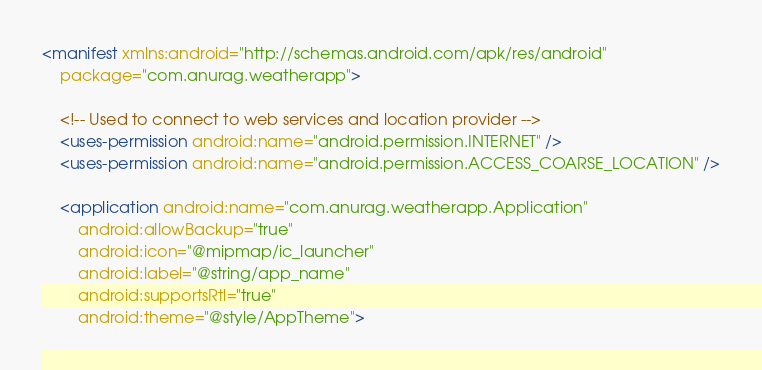Convert code to text. <code><loc_0><loc_0><loc_500><loc_500><_XML_><manifest xmlns:android="http://schemas.android.com/apk/res/android"
    package="com.anurag.weatherapp">

    <!-- Used to connect to web services and location provider -->
    <uses-permission android:name="android.permission.INTERNET" />
    <uses-permission android:name="android.permission.ACCESS_COARSE_LOCATION" />

    <application android:name="com.anurag.weatherapp.Application"
        android:allowBackup="true"
        android:icon="@mipmap/ic_launcher"
        android:label="@string/app_name"
        android:supportsRtl="true"
        android:theme="@style/AppTheme"></code> 